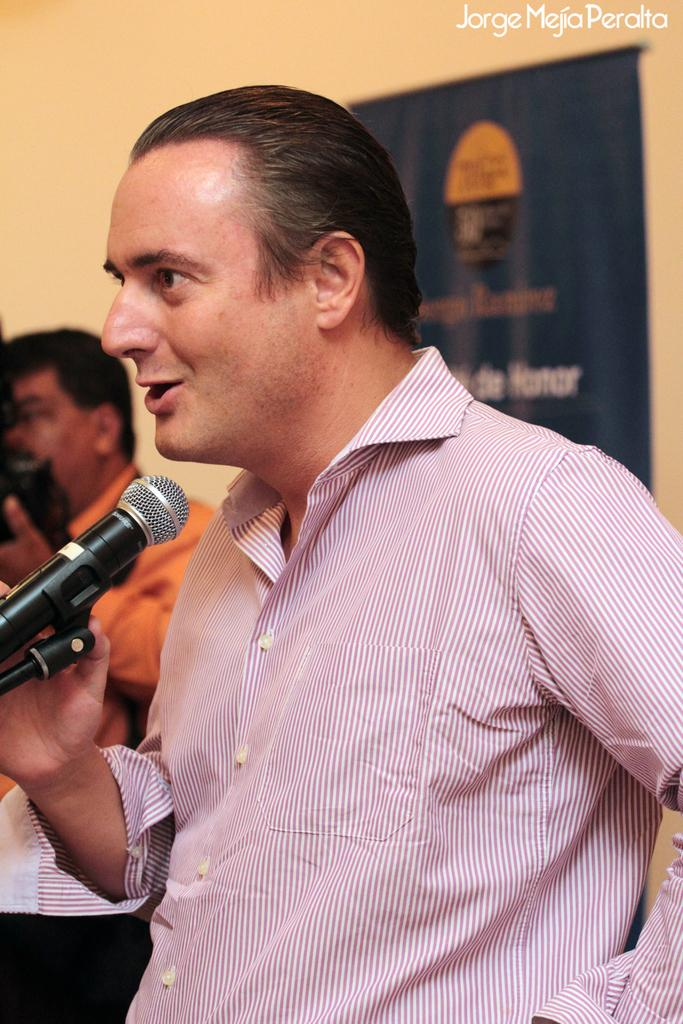What is the man in the image doing? The man is standing in the image and talking into a microphone. What can be seen in the background of the image? There is a poster attached to a wall in the background, and there is a person standing in the background. How many clocks are visible in the image? There are no clocks visible in the image. What type of print is featured on the poster in the background? The provided facts do not mention the type of print on the poster, so we cannot answer this question definitively. 